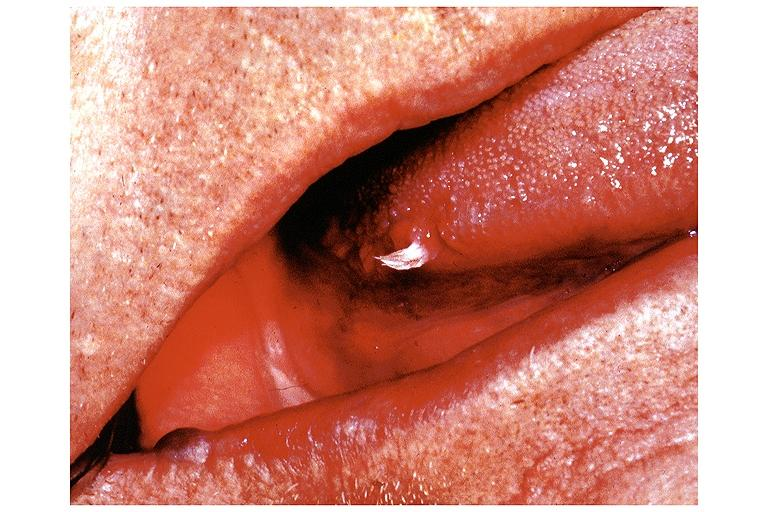where is this?
Answer the question using a single word or phrase. Oral 